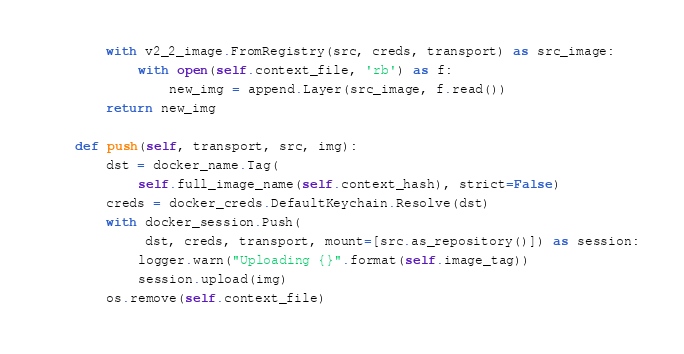<code> <loc_0><loc_0><loc_500><loc_500><_Python_>        with v2_2_image.FromRegistry(src, creds, transport) as src_image:
            with open(self.context_file, 'rb') as f:
                new_img = append.Layer(src_image, f.read())
        return new_img

    def push(self, transport, src, img):
        dst = docker_name.Tag(
            self.full_image_name(self.context_hash), strict=False)
        creds = docker_creds.DefaultKeychain.Resolve(dst)
        with docker_session.Push(
             dst, creds, transport, mount=[src.as_repository()]) as session:
            logger.warn("Uploading {}".format(self.image_tag))
            session.upload(img)
        os.remove(self.context_file)
</code> 